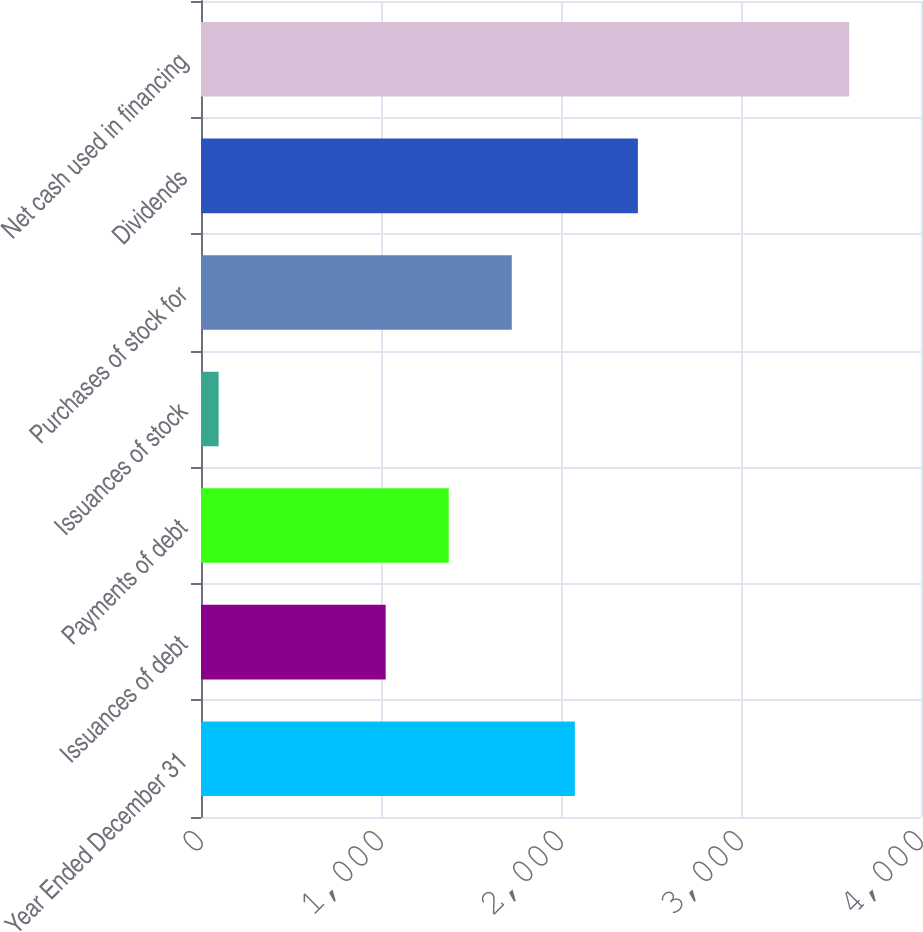Convert chart. <chart><loc_0><loc_0><loc_500><loc_500><bar_chart><fcel>Year Ended December 31<fcel>Issuances of debt<fcel>Payments of debt<fcel>Issuances of stock<fcel>Purchases of stock for<fcel>Dividends<fcel>Net cash used in financing<nl><fcel>2076.9<fcel>1026<fcel>1376.3<fcel>98<fcel>1726.6<fcel>2427.2<fcel>3601<nl></chart> 